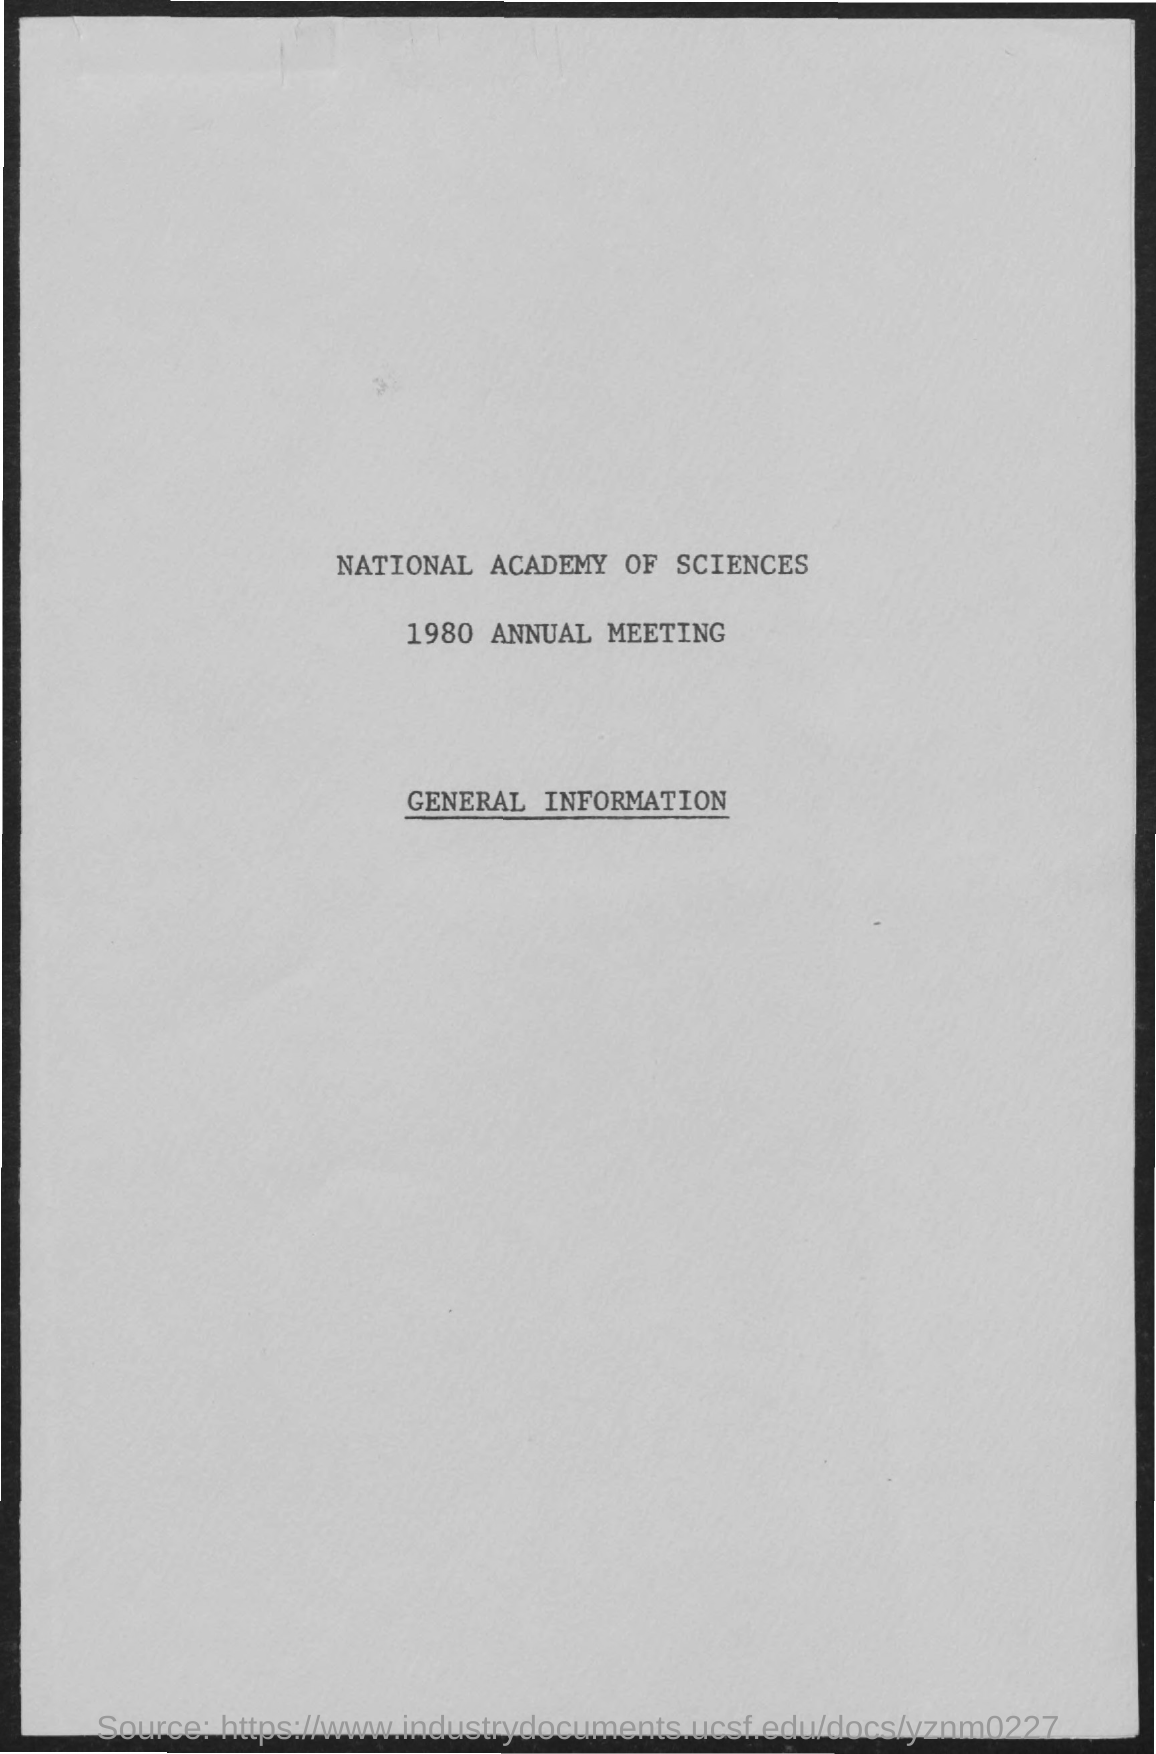List a handful of essential elements in this visual. The annual meeting took place in 1980. 